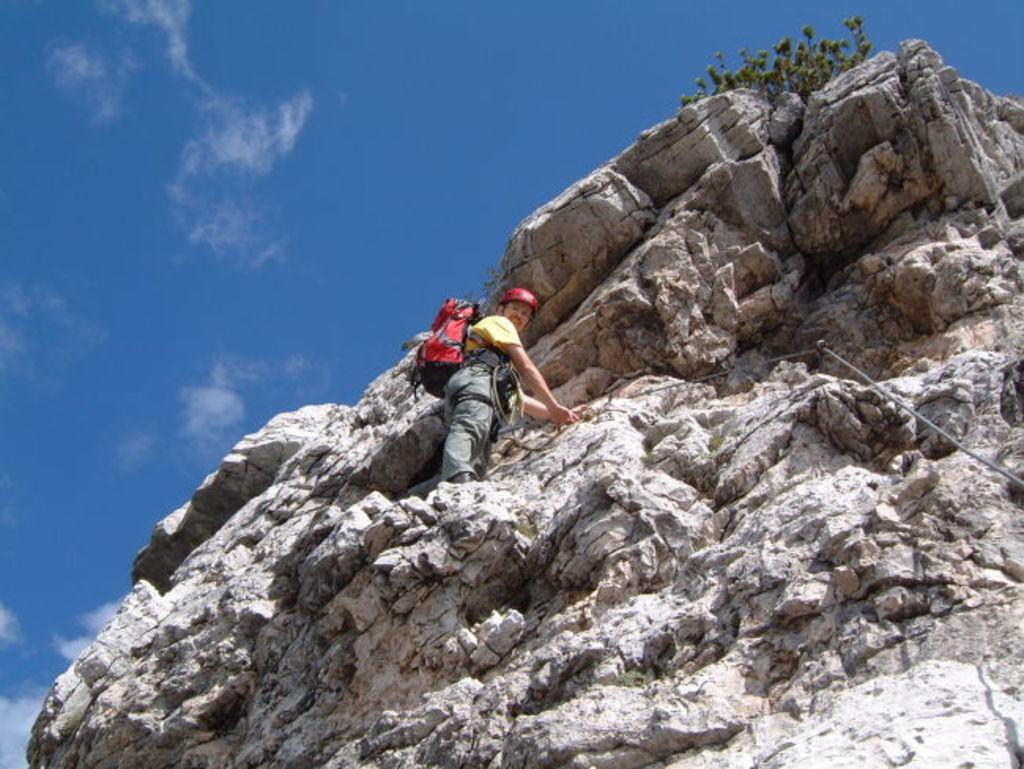What is the main subject of the image? There is a person standing on a mountain in the image. What can be seen in the background of the image? The sky is visible in the background of the image. What is the weight of the middle station in the image? There is no middle station present in the image, as it features a person standing on a mountain with the sky visible in the background. 